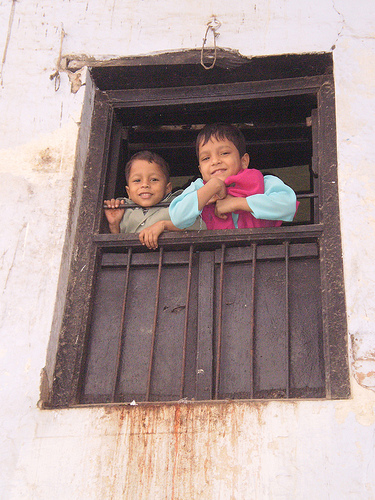<image>
Can you confirm if the kid one is in front of the kid two? No. The kid one is not in front of the kid two. The spatial positioning shows a different relationship between these objects. 